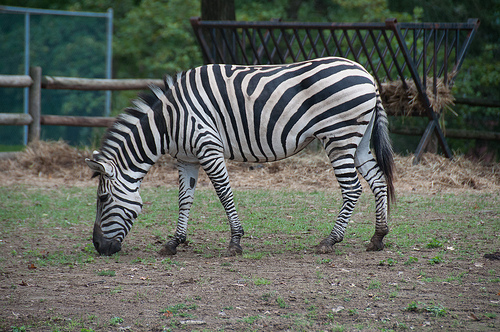Please provide a short description for this region: [0.52, 0.34, 0.6, 0.41]. This region beautifully displays the iconic black stripes on a zebra, which are an evolutionary adaptation for camouflage and social interaction. 